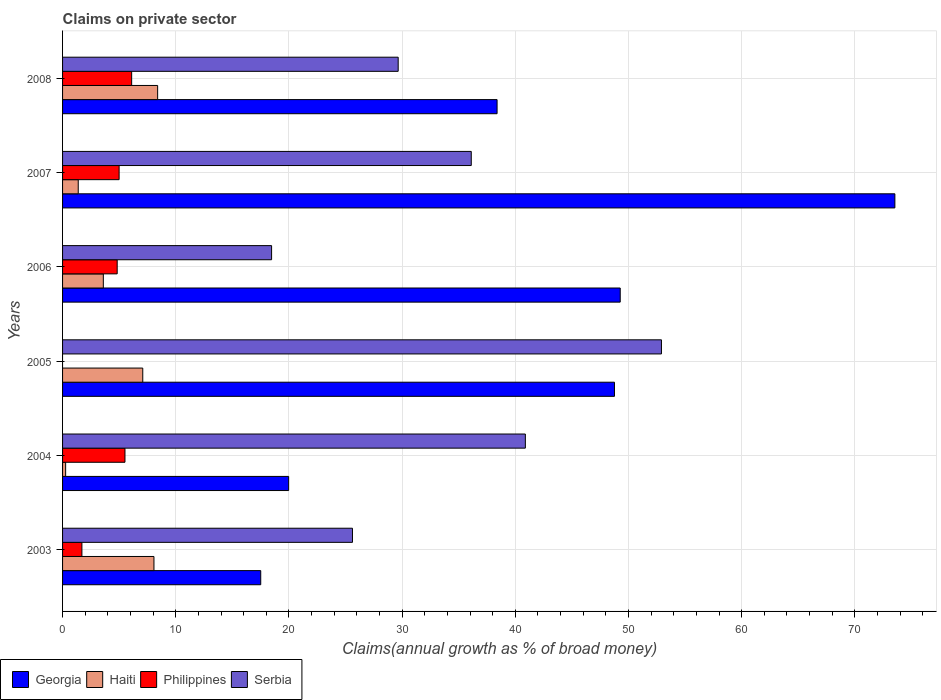What is the label of the 3rd group of bars from the top?
Give a very brief answer. 2006. In how many cases, is the number of bars for a given year not equal to the number of legend labels?
Give a very brief answer. 1. What is the percentage of broad money claimed on private sector in Serbia in 2004?
Make the answer very short. 40.89. Across all years, what is the maximum percentage of broad money claimed on private sector in Haiti?
Your answer should be compact. 8.4. Across all years, what is the minimum percentage of broad money claimed on private sector in Georgia?
Offer a terse response. 17.51. What is the total percentage of broad money claimed on private sector in Philippines in the graph?
Keep it short and to the point. 23.15. What is the difference between the percentage of broad money claimed on private sector in Georgia in 2003 and that in 2004?
Keep it short and to the point. -2.47. What is the difference between the percentage of broad money claimed on private sector in Serbia in 2006 and the percentage of broad money claimed on private sector in Georgia in 2005?
Provide a short and direct response. -30.29. What is the average percentage of broad money claimed on private sector in Philippines per year?
Provide a short and direct response. 3.86. In the year 2006, what is the difference between the percentage of broad money claimed on private sector in Serbia and percentage of broad money claimed on private sector in Georgia?
Your response must be concise. -30.8. What is the ratio of the percentage of broad money claimed on private sector in Philippines in 2006 to that in 2007?
Keep it short and to the point. 0.97. What is the difference between the highest and the second highest percentage of broad money claimed on private sector in Georgia?
Keep it short and to the point. 24.27. What is the difference between the highest and the lowest percentage of broad money claimed on private sector in Haiti?
Offer a terse response. 8.13. In how many years, is the percentage of broad money claimed on private sector in Philippines greater than the average percentage of broad money claimed on private sector in Philippines taken over all years?
Ensure brevity in your answer.  4. Is the sum of the percentage of broad money claimed on private sector in Georgia in 2004 and 2008 greater than the maximum percentage of broad money claimed on private sector in Philippines across all years?
Your response must be concise. Yes. Is it the case that in every year, the sum of the percentage of broad money claimed on private sector in Georgia and percentage of broad money claimed on private sector in Philippines is greater than the percentage of broad money claimed on private sector in Haiti?
Your answer should be compact. Yes. How many bars are there?
Your answer should be very brief. 23. Does the graph contain any zero values?
Your answer should be very brief. Yes. Where does the legend appear in the graph?
Offer a very short reply. Bottom left. What is the title of the graph?
Ensure brevity in your answer.  Claims on private sector. Does "Mexico" appear as one of the legend labels in the graph?
Make the answer very short. No. What is the label or title of the X-axis?
Offer a very short reply. Claims(annual growth as % of broad money). What is the label or title of the Y-axis?
Your answer should be very brief. Years. What is the Claims(annual growth as % of broad money) of Georgia in 2003?
Ensure brevity in your answer.  17.51. What is the Claims(annual growth as % of broad money) in Haiti in 2003?
Provide a succinct answer. 8.08. What is the Claims(annual growth as % of broad money) in Philippines in 2003?
Provide a succinct answer. 1.71. What is the Claims(annual growth as % of broad money) in Serbia in 2003?
Ensure brevity in your answer.  25.61. What is the Claims(annual growth as % of broad money) in Georgia in 2004?
Your response must be concise. 19.98. What is the Claims(annual growth as % of broad money) of Haiti in 2004?
Offer a terse response. 0.27. What is the Claims(annual growth as % of broad money) of Philippines in 2004?
Offer a very short reply. 5.51. What is the Claims(annual growth as % of broad money) in Serbia in 2004?
Provide a succinct answer. 40.89. What is the Claims(annual growth as % of broad money) in Georgia in 2005?
Your response must be concise. 48.76. What is the Claims(annual growth as % of broad money) in Haiti in 2005?
Your answer should be compact. 7.09. What is the Claims(annual growth as % of broad money) of Philippines in 2005?
Make the answer very short. 0. What is the Claims(annual growth as % of broad money) of Serbia in 2005?
Offer a terse response. 52.91. What is the Claims(annual growth as % of broad money) in Georgia in 2006?
Give a very brief answer. 49.27. What is the Claims(annual growth as % of broad money) in Haiti in 2006?
Give a very brief answer. 3.6. What is the Claims(annual growth as % of broad money) in Philippines in 2006?
Your answer should be very brief. 4.83. What is the Claims(annual growth as % of broad money) in Serbia in 2006?
Provide a succinct answer. 18.47. What is the Claims(annual growth as % of broad money) in Georgia in 2007?
Ensure brevity in your answer.  73.54. What is the Claims(annual growth as % of broad money) in Haiti in 2007?
Make the answer very short. 1.38. What is the Claims(annual growth as % of broad money) in Philippines in 2007?
Your answer should be compact. 5. What is the Claims(annual growth as % of broad money) in Serbia in 2007?
Your response must be concise. 36.11. What is the Claims(annual growth as % of broad money) of Georgia in 2008?
Offer a terse response. 38.39. What is the Claims(annual growth as % of broad money) in Haiti in 2008?
Keep it short and to the point. 8.4. What is the Claims(annual growth as % of broad money) in Philippines in 2008?
Provide a succinct answer. 6.1. What is the Claims(annual growth as % of broad money) of Serbia in 2008?
Keep it short and to the point. 29.65. Across all years, what is the maximum Claims(annual growth as % of broad money) in Georgia?
Ensure brevity in your answer.  73.54. Across all years, what is the maximum Claims(annual growth as % of broad money) of Haiti?
Offer a very short reply. 8.4. Across all years, what is the maximum Claims(annual growth as % of broad money) of Philippines?
Give a very brief answer. 6.1. Across all years, what is the maximum Claims(annual growth as % of broad money) of Serbia?
Offer a terse response. 52.91. Across all years, what is the minimum Claims(annual growth as % of broad money) of Georgia?
Give a very brief answer. 17.51. Across all years, what is the minimum Claims(annual growth as % of broad money) in Haiti?
Offer a terse response. 0.27. Across all years, what is the minimum Claims(annual growth as % of broad money) of Philippines?
Your answer should be very brief. 0. Across all years, what is the minimum Claims(annual growth as % of broad money) of Serbia?
Give a very brief answer. 18.47. What is the total Claims(annual growth as % of broad money) of Georgia in the graph?
Ensure brevity in your answer.  247.45. What is the total Claims(annual growth as % of broad money) in Haiti in the graph?
Offer a very short reply. 28.82. What is the total Claims(annual growth as % of broad money) in Philippines in the graph?
Give a very brief answer. 23.15. What is the total Claims(annual growth as % of broad money) in Serbia in the graph?
Make the answer very short. 203.65. What is the difference between the Claims(annual growth as % of broad money) of Georgia in 2003 and that in 2004?
Give a very brief answer. -2.47. What is the difference between the Claims(annual growth as % of broad money) in Haiti in 2003 and that in 2004?
Offer a very short reply. 7.8. What is the difference between the Claims(annual growth as % of broad money) of Philippines in 2003 and that in 2004?
Your response must be concise. -3.8. What is the difference between the Claims(annual growth as % of broad money) of Serbia in 2003 and that in 2004?
Your response must be concise. -15.28. What is the difference between the Claims(annual growth as % of broad money) in Georgia in 2003 and that in 2005?
Offer a very short reply. -31.25. What is the difference between the Claims(annual growth as % of broad money) of Haiti in 2003 and that in 2005?
Ensure brevity in your answer.  0.99. What is the difference between the Claims(annual growth as % of broad money) in Serbia in 2003 and that in 2005?
Offer a terse response. -27.3. What is the difference between the Claims(annual growth as % of broad money) in Georgia in 2003 and that in 2006?
Your response must be concise. -31.76. What is the difference between the Claims(annual growth as % of broad money) of Haiti in 2003 and that in 2006?
Keep it short and to the point. 4.47. What is the difference between the Claims(annual growth as % of broad money) of Philippines in 2003 and that in 2006?
Offer a very short reply. -3.12. What is the difference between the Claims(annual growth as % of broad money) of Serbia in 2003 and that in 2006?
Offer a terse response. 7.15. What is the difference between the Claims(annual growth as % of broad money) in Georgia in 2003 and that in 2007?
Give a very brief answer. -56.03. What is the difference between the Claims(annual growth as % of broad money) in Haiti in 2003 and that in 2007?
Ensure brevity in your answer.  6.69. What is the difference between the Claims(annual growth as % of broad money) of Philippines in 2003 and that in 2007?
Offer a very short reply. -3.29. What is the difference between the Claims(annual growth as % of broad money) in Serbia in 2003 and that in 2007?
Your answer should be compact. -10.5. What is the difference between the Claims(annual growth as % of broad money) in Georgia in 2003 and that in 2008?
Your response must be concise. -20.88. What is the difference between the Claims(annual growth as % of broad money) in Haiti in 2003 and that in 2008?
Make the answer very short. -0.33. What is the difference between the Claims(annual growth as % of broad money) of Philippines in 2003 and that in 2008?
Offer a very short reply. -4.4. What is the difference between the Claims(annual growth as % of broad money) in Serbia in 2003 and that in 2008?
Ensure brevity in your answer.  -4.04. What is the difference between the Claims(annual growth as % of broad money) in Georgia in 2004 and that in 2005?
Provide a succinct answer. -28.79. What is the difference between the Claims(annual growth as % of broad money) of Haiti in 2004 and that in 2005?
Offer a very short reply. -6.81. What is the difference between the Claims(annual growth as % of broad money) of Serbia in 2004 and that in 2005?
Your answer should be very brief. -12.02. What is the difference between the Claims(annual growth as % of broad money) of Georgia in 2004 and that in 2006?
Provide a succinct answer. -29.3. What is the difference between the Claims(annual growth as % of broad money) of Haiti in 2004 and that in 2006?
Offer a terse response. -3.33. What is the difference between the Claims(annual growth as % of broad money) in Philippines in 2004 and that in 2006?
Your response must be concise. 0.69. What is the difference between the Claims(annual growth as % of broad money) in Serbia in 2004 and that in 2006?
Make the answer very short. 22.42. What is the difference between the Claims(annual growth as % of broad money) of Georgia in 2004 and that in 2007?
Your response must be concise. -53.56. What is the difference between the Claims(annual growth as % of broad money) in Haiti in 2004 and that in 2007?
Ensure brevity in your answer.  -1.11. What is the difference between the Claims(annual growth as % of broad money) of Philippines in 2004 and that in 2007?
Your answer should be very brief. 0.52. What is the difference between the Claims(annual growth as % of broad money) of Serbia in 2004 and that in 2007?
Provide a succinct answer. 4.78. What is the difference between the Claims(annual growth as % of broad money) in Georgia in 2004 and that in 2008?
Offer a terse response. -18.42. What is the difference between the Claims(annual growth as % of broad money) of Haiti in 2004 and that in 2008?
Make the answer very short. -8.13. What is the difference between the Claims(annual growth as % of broad money) of Philippines in 2004 and that in 2008?
Make the answer very short. -0.59. What is the difference between the Claims(annual growth as % of broad money) of Serbia in 2004 and that in 2008?
Provide a short and direct response. 11.24. What is the difference between the Claims(annual growth as % of broad money) in Georgia in 2005 and that in 2006?
Your response must be concise. -0.51. What is the difference between the Claims(annual growth as % of broad money) of Haiti in 2005 and that in 2006?
Your answer should be compact. 3.48. What is the difference between the Claims(annual growth as % of broad money) in Serbia in 2005 and that in 2006?
Provide a short and direct response. 34.45. What is the difference between the Claims(annual growth as % of broad money) of Georgia in 2005 and that in 2007?
Make the answer very short. -24.78. What is the difference between the Claims(annual growth as % of broad money) of Haiti in 2005 and that in 2007?
Provide a succinct answer. 5.7. What is the difference between the Claims(annual growth as % of broad money) of Serbia in 2005 and that in 2007?
Give a very brief answer. 16.8. What is the difference between the Claims(annual growth as % of broad money) of Georgia in 2005 and that in 2008?
Offer a very short reply. 10.37. What is the difference between the Claims(annual growth as % of broad money) of Haiti in 2005 and that in 2008?
Your response must be concise. -1.32. What is the difference between the Claims(annual growth as % of broad money) in Serbia in 2005 and that in 2008?
Provide a succinct answer. 23.26. What is the difference between the Claims(annual growth as % of broad money) of Georgia in 2006 and that in 2007?
Keep it short and to the point. -24.27. What is the difference between the Claims(annual growth as % of broad money) in Haiti in 2006 and that in 2007?
Your answer should be very brief. 2.22. What is the difference between the Claims(annual growth as % of broad money) in Philippines in 2006 and that in 2007?
Provide a short and direct response. -0.17. What is the difference between the Claims(annual growth as % of broad money) of Serbia in 2006 and that in 2007?
Offer a terse response. -17.64. What is the difference between the Claims(annual growth as % of broad money) of Georgia in 2006 and that in 2008?
Your answer should be very brief. 10.88. What is the difference between the Claims(annual growth as % of broad money) in Haiti in 2006 and that in 2008?
Provide a short and direct response. -4.8. What is the difference between the Claims(annual growth as % of broad money) of Philippines in 2006 and that in 2008?
Offer a terse response. -1.28. What is the difference between the Claims(annual growth as % of broad money) of Serbia in 2006 and that in 2008?
Provide a short and direct response. -11.18. What is the difference between the Claims(annual growth as % of broad money) in Georgia in 2007 and that in 2008?
Make the answer very short. 35.15. What is the difference between the Claims(annual growth as % of broad money) of Haiti in 2007 and that in 2008?
Give a very brief answer. -7.02. What is the difference between the Claims(annual growth as % of broad money) in Philippines in 2007 and that in 2008?
Keep it short and to the point. -1.11. What is the difference between the Claims(annual growth as % of broad money) in Serbia in 2007 and that in 2008?
Offer a very short reply. 6.46. What is the difference between the Claims(annual growth as % of broad money) in Georgia in 2003 and the Claims(annual growth as % of broad money) in Haiti in 2004?
Provide a succinct answer. 17.24. What is the difference between the Claims(annual growth as % of broad money) of Georgia in 2003 and the Claims(annual growth as % of broad money) of Philippines in 2004?
Your answer should be very brief. 12. What is the difference between the Claims(annual growth as % of broad money) of Georgia in 2003 and the Claims(annual growth as % of broad money) of Serbia in 2004?
Your answer should be very brief. -23.38. What is the difference between the Claims(annual growth as % of broad money) of Haiti in 2003 and the Claims(annual growth as % of broad money) of Philippines in 2004?
Keep it short and to the point. 2.56. What is the difference between the Claims(annual growth as % of broad money) in Haiti in 2003 and the Claims(annual growth as % of broad money) in Serbia in 2004?
Provide a short and direct response. -32.81. What is the difference between the Claims(annual growth as % of broad money) of Philippines in 2003 and the Claims(annual growth as % of broad money) of Serbia in 2004?
Offer a terse response. -39.18. What is the difference between the Claims(annual growth as % of broad money) of Georgia in 2003 and the Claims(annual growth as % of broad money) of Haiti in 2005?
Offer a terse response. 10.42. What is the difference between the Claims(annual growth as % of broad money) in Georgia in 2003 and the Claims(annual growth as % of broad money) in Serbia in 2005?
Your response must be concise. -35.4. What is the difference between the Claims(annual growth as % of broad money) of Haiti in 2003 and the Claims(annual growth as % of broad money) of Serbia in 2005?
Your response must be concise. -44.84. What is the difference between the Claims(annual growth as % of broad money) in Philippines in 2003 and the Claims(annual growth as % of broad money) in Serbia in 2005?
Offer a very short reply. -51.21. What is the difference between the Claims(annual growth as % of broad money) of Georgia in 2003 and the Claims(annual growth as % of broad money) of Haiti in 2006?
Your answer should be compact. 13.91. What is the difference between the Claims(annual growth as % of broad money) in Georgia in 2003 and the Claims(annual growth as % of broad money) in Philippines in 2006?
Make the answer very short. 12.68. What is the difference between the Claims(annual growth as % of broad money) in Georgia in 2003 and the Claims(annual growth as % of broad money) in Serbia in 2006?
Provide a succinct answer. -0.96. What is the difference between the Claims(annual growth as % of broad money) of Haiti in 2003 and the Claims(annual growth as % of broad money) of Philippines in 2006?
Make the answer very short. 3.25. What is the difference between the Claims(annual growth as % of broad money) in Haiti in 2003 and the Claims(annual growth as % of broad money) in Serbia in 2006?
Your response must be concise. -10.39. What is the difference between the Claims(annual growth as % of broad money) of Philippines in 2003 and the Claims(annual growth as % of broad money) of Serbia in 2006?
Your response must be concise. -16.76. What is the difference between the Claims(annual growth as % of broad money) in Georgia in 2003 and the Claims(annual growth as % of broad money) in Haiti in 2007?
Your answer should be very brief. 16.13. What is the difference between the Claims(annual growth as % of broad money) in Georgia in 2003 and the Claims(annual growth as % of broad money) in Philippines in 2007?
Ensure brevity in your answer.  12.51. What is the difference between the Claims(annual growth as % of broad money) in Georgia in 2003 and the Claims(annual growth as % of broad money) in Serbia in 2007?
Ensure brevity in your answer.  -18.6. What is the difference between the Claims(annual growth as % of broad money) of Haiti in 2003 and the Claims(annual growth as % of broad money) of Philippines in 2007?
Give a very brief answer. 3.08. What is the difference between the Claims(annual growth as % of broad money) of Haiti in 2003 and the Claims(annual growth as % of broad money) of Serbia in 2007?
Offer a terse response. -28.04. What is the difference between the Claims(annual growth as % of broad money) of Philippines in 2003 and the Claims(annual growth as % of broad money) of Serbia in 2007?
Offer a very short reply. -34.4. What is the difference between the Claims(annual growth as % of broad money) in Georgia in 2003 and the Claims(annual growth as % of broad money) in Haiti in 2008?
Offer a terse response. 9.11. What is the difference between the Claims(annual growth as % of broad money) of Georgia in 2003 and the Claims(annual growth as % of broad money) of Philippines in 2008?
Offer a very short reply. 11.41. What is the difference between the Claims(annual growth as % of broad money) in Georgia in 2003 and the Claims(annual growth as % of broad money) in Serbia in 2008?
Keep it short and to the point. -12.14. What is the difference between the Claims(annual growth as % of broad money) of Haiti in 2003 and the Claims(annual growth as % of broad money) of Philippines in 2008?
Make the answer very short. 1.97. What is the difference between the Claims(annual growth as % of broad money) in Haiti in 2003 and the Claims(annual growth as % of broad money) in Serbia in 2008?
Keep it short and to the point. -21.58. What is the difference between the Claims(annual growth as % of broad money) of Philippines in 2003 and the Claims(annual growth as % of broad money) of Serbia in 2008?
Your answer should be very brief. -27.94. What is the difference between the Claims(annual growth as % of broad money) in Georgia in 2004 and the Claims(annual growth as % of broad money) in Haiti in 2005?
Make the answer very short. 12.89. What is the difference between the Claims(annual growth as % of broad money) of Georgia in 2004 and the Claims(annual growth as % of broad money) of Serbia in 2005?
Offer a very short reply. -32.94. What is the difference between the Claims(annual growth as % of broad money) of Haiti in 2004 and the Claims(annual growth as % of broad money) of Serbia in 2005?
Your response must be concise. -52.64. What is the difference between the Claims(annual growth as % of broad money) of Philippines in 2004 and the Claims(annual growth as % of broad money) of Serbia in 2005?
Make the answer very short. -47.4. What is the difference between the Claims(annual growth as % of broad money) of Georgia in 2004 and the Claims(annual growth as % of broad money) of Haiti in 2006?
Your answer should be very brief. 16.38. What is the difference between the Claims(annual growth as % of broad money) in Georgia in 2004 and the Claims(annual growth as % of broad money) in Philippines in 2006?
Your answer should be compact. 15.15. What is the difference between the Claims(annual growth as % of broad money) of Georgia in 2004 and the Claims(annual growth as % of broad money) of Serbia in 2006?
Give a very brief answer. 1.51. What is the difference between the Claims(annual growth as % of broad money) of Haiti in 2004 and the Claims(annual growth as % of broad money) of Philippines in 2006?
Provide a succinct answer. -4.56. What is the difference between the Claims(annual growth as % of broad money) in Haiti in 2004 and the Claims(annual growth as % of broad money) in Serbia in 2006?
Make the answer very short. -18.2. What is the difference between the Claims(annual growth as % of broad money) in Philippines in 2004 and the Claims(annual growth as % of broad money) in Serbia in 2006?
Offer a terse response. -12.96. What is the difference between the Claims(annual growth as % of broad money) of Georgia in 2004 and the Claims(annual growth as % of broad money) of Haiti in 2007?
Your answer should be very brief. 18.59. What is the difference between the Claims(annual growth as % of broad money) of Georgia in 2004 and the Claims(annual growth as % of broad money) of Philippines in 2007?
Give a very brief answer. 14.98. What is the difference between the Claims(annual growth as % of broad money) in Georgia in 2004 and the Claims(annual growth as % of broad money) in Serbia in 2007?
Provide a short and direct response. -16.13. What is the difference between the Claims(annual growth as % of broad money) in Haiti in 2004 and the Claims(annual growth as % of broad money) in Philippines in 2007?
Provide a short and direct response. -4.73. What is the difference between the Claims(annual growth as % of broad money) of Haiti in 2004 and the Claims(annual growth as % of broad money) of Serbia in 2007?
Give a very brief answer. -35.84. What is the difference between the Claims(annual growth as % of broad money) in Philippines in 2004 and the Claims(annual growth as % of broad money) in Serbia in 2007?
Keep it short and to the point. -30.6. What is the difference between the Claims(annual growth as % of broad money) of Georgia in 2004 and the Claims(annual growth as % of broad money) of Haiti in 2008?
Your response must be concise. 11.58. What is the difference between the Claims(annual growth as % of broad money) of Georgia in 2004 and the Claims(annual growth as % of broad money) of Philippines in 2008?
Give a very brief answer. 13.87. What is the difference between the Claims(annual growth as % of broad money) in Georgia in 2004 and the Claims(annual growth as % of broad money) in Serbia in 2008?
Provide a short and direct response. -9.68. What is the difference between the Claims(annual growth as % of broad money) of Haiti in 2004 and the Claims(annual growth as % of broad money) of Philippines in 2008?
Your response must be concise. -5.83. What is the difference between the Claims(annual growth as % of broad money) of Haiti in 2004 and the Claims(annual growth as % of broad money) of Serbia in 2008?
Make the answer very short. -29.38. What is the difference between the Claims(annual growth as % of broad money) of Philippines in 2004 and the Claims(annual growth as % of broad money) of Serbia in 2008?
Your answer should be very brief. -24.14. What is the difference between the Claims(annual growth as % of broad money) of Georgia in 2005 and the Claims(annual growth as % of broad money) of Haiti in 2006?
Provide a succinct answer. 45.16. What is the difference between the Claims(annual growth as % of broad money) in Georgia in 2005 and the Claims(annual growth as % of broad money) in Philippines in 2006?
Offer a very short reply. 43.94. What is the difference between the Claims(annual growth as % of broad money) of Georgia in 2005 and the Claims(annual growth as % of broad money) of Serbia in 2006?
Offer a very short reply. 30.29. What is the difference between the Claims(annual growth as % of broad money) of Haiti in 2005 and the Claims(annual growth as % of broad money) of Philippines in 2006?
Provide a short and direct response. 2.26. What is the difference between the Claims(annual growth as % of broad money) of Haiti in 2005 and the Claims(annual growth as % of broad money) of Serbia in 2006?
Offer a very short reply. -11.38. What is the difference between the Claims(annual growth as % of broad money) in Georgia in 2005 and the Claims(annual growth as % of broad money) in Haiti in 2007?
Make the answer very short. 47.38. What is the difference between the Claims(annual growth as % of broad money) of Georgia in 2005 and the Claims(annual growth as % of broad money) of Philippines in 2007?
Your answer should be compact. 43.77. What is the difference between the Claims(annual growth as % of broad money) in Georgia in 2005 and the Claims(annual growth as % of broad money) in Serbia in 2007?
Your answer should be very brief. 12.65. What is the difference between the Claims(annual growth as % of broad money) of Haiti in 2005 and the Claims(annual growth as % of broad money) of Philippines in 2007?
Make the answer very short. 2.09. What is the difference between the Claims(annual growth as % of broad money) of Haiti in 2005 and the Claims(annual growth as % of broad money) of Serbia in 2007?
Keep it short and to the point. -29.03. What is the difference between the Claims(annual growth as % of broad money) of Georgia in 2005 and the Claims(annual growth as % of broad money) of Haiti in 2008?
Your answer should be compact. 40.36. What is the difference between the Claims(annual growth as % of broad money) of Georgia in 2005 and the Claims(annual growth as % of broad money) of Philippines in 2008?
Provide a short and direct response. 42.66. What is the difference between the Claims(annual growth as % of broad money) of Georgia in 2005 and the Claims(annual growth as % of broad money) of Serbia in 2008?
Your response must be concise. 19.11. What is the difference between the Claims(annual growth as % of broad money) of Haiti in 2005 and the Claims(annual growth as % of broad money) of Philippines in 2008?
Provide a short and direct response. 0.98. What is the difference between the Claims(annual growth as % of broad money) of Haiti in 2005 and the Claims(annual growth as % of broad money) of Serbia in 2008?
Keep it short and to the point. -22.57. What is the difference between the Claims(annual growth as % of broad money) in Georgia in 2006 and the Claims(annual growth as % of broad money) in Haiti in 2007?
Your answer should be compact. 47.89. What is the difference between the Claims(annual growth as % of broad money) in Georgia in 2006 and the Claims(annual growth as % of broad money) in Philippines in 2007?
Keep it short and to the point. 44.28. What is the difference between the Claims(annual growth as % of broad money) in Georgia in 2006 and the Claims(annual growth as % of broad money) in Serbia in 2007?
Your answer should be very brief. 13.16. What is the difference between the Claims(annual growth as % of broad money) in Haiti in 2006 and the Claims(annual growth as % of broad money) in Philippines in 2007?
Provide a short and direct response. -1.4. What is the difference between the Claims(annual growth as % of broad money) of Haiti in 2006 and the Claims(annual growth as % of broad money) of Serbia in 2007?
Make the answer very short. -32.51. What is the difference between the Claims(annual growth as % of broad money) in Philippines in 2006 and the Claims(annual growth as % of broad money) in Serbia in 2007?
Provide a succinct answer. -31.28. What is the difference between the Claims(annual growth as % of broad money) of Georgia in 2006 and the Claims(annual growth as % of broad money) of Haiti in 2008?
Give a very brief answer. 40.87. What is the difference between the Claims(annual growth as % of broad money) of Georgia in 2006 and the Claims(annual growth as % of broad money) of Philippines in 2008?
Provide a short and direct response. 43.17. What is the difference between the Claims(annual growth as % of broad money) of Georgia in 2006 and the Claims(annual growth as % of broad money) of Serbia in 2008?
Provide a succinct answer. 19.62. What is the difference between the Claims(annual growth as % of broad money) in Haiti in 2006 and the Claims(annual growth as % of broad money) in Philippines in 2008?
Your response must be concise. -2.5. What is the difference between the Claims(annual growth as % of broad money) in Haiti in 2006 and the Claims(annual growth as % of broad money) in Serbia in 2008?
Offer a terse response. -26.05. What is the difference between the Claims(annual growth as % of broad money) of Philippines in 2006 and the Claims(annual growth as % of broad money) of Serbia in 2008?
Provide a succinct answer. -24.83. What is the difference between the Claims(annual growth as % of broad money) in Georgia in 2007 and the Claims(annual growth as % of broad money) in Haiti in 2008?
Offer a terse response. 65.14. What is the difference between the Claims(annual growth as % of broad money) in Georgia in 2007 and the Claims(annual growth as % of broad money) in Philippines in 2008?
Ensure brevity in your answer.  67.43. What is the difference between the Claims(annual growth as % of broad money) of Georgia in 2007 and the Claims(annual growth as % of broad money) of Serbia in 2008?
Keep it short and to the point. 43.89. What is the difference between the Claims(annual growth as % of broad money) of Haiti in 2007 and the Claims(annual growth as % of broad money) of Philippines in 2008?
Make the answer very short. -4.72. What is the difference between the Claims(annual growth as % of broad money) in Haiti in 2007 and the Claims(annual growth as % of broad money) in Serbia in 2008?
Keep it short and to the point. -28.27. What is the difference between the Claims(annual growth as % of broad money) in Philippines in 2007 and the Claims(annual growth as % of broad money) in Serbia in 2008?
Make the answer very short. -24.66. What is the average Claims(annual growth as % of broad money) of Georgia per year?
Offer a terse response. 41.24. What is the average Claims(annual growth as % of broad money) of Haiti per year?
Provide a succinct answer. 4.8. What is the average Claims(annual growth as % of broad money) of Philippines per year?
Give a very brief answer. 3.86. What is the average Claims(annual growth as % of broad money) in Serbia per year?
Give a very brief answer. 33.94. In the year 2003, what is the difference between the Claims(annual growth as % of broad money) of Georgia and Claims(annual growth as % of broad money) of Haiti?
Provide a short and direct response. 9.43. In the year 2003, what is the difference between the Claims(annual growth as % of broad money) of Georgia and Claims(annual growth as % of broad money) of Philippines?
Provide a short and direct response. 15.8. In the year 2003, what is the difference between the Claims(annual growth as % of broad money) in Georgia and Claims(annual growth as % of broad money) in Serbia?
Keep it short and to the point. -8.1. In the year 2003, what is the difference between the Claims(annual growth as % of broad money) in Haiti and Claims(annual growth as % of broad money) in Philippines?
Your answer should be very brief. 6.37. In the year 2003, what is the difference between the Claims(annual growth as % of broad money) of Haiti and Claims(annual growth as % of broad money) of Serbia?
Offer a terse response. -17.54. In the year 2003, what is the difference between the Claims(annual growth as % of broad money) in Philippines and Claims(annual growth as % of broad money) in Serbia?
Make the answer very short. -23.91. In the year 2004, what is the difference between the Claims(annual growth as % of broad money) of Georgia and Claims(annual growth as % of broad money) of Haiti?
Offer a very short reply. 19.71. In the year 2004, what is the difference between the Claims(annual growth as % of broad money) of Georgia and Claims(annual growth as % of broad money) of Philippines?
Offer a very short reply. 14.46. In the year 2004, what is the difference between the Claims(annual growth as % of broad money) in Georgia and Claims(annual growth as % of broad money) in Serbia?
Provide a succinct answer. -20.91. In the year 2004, what is the difference between the Claims(annual growth as % of broad money) of Haiti and Claims(annual growth as % of broad money) of Philippines?
Provide a succinct answer. -5.24. In the year 2004, what is the difference between the Claims(annual growth as % of broad money) in Haiti and Claims(annual growth as % of broad money) in Serbia?
Provide a short and direct response. -40.62. In the year 2004, what is the difference between the Claims(annual growth as % of broad money) in Philippines and Claims(annual growth as % of broad money) in Serbia?
Provide a succinct answer. -35.38. In the year 2005, what is the difference between the Claims(annual growth as % of broad money) of Georgia and Claims(annual growth as % of broad money) of Haiti?
Make the answer very short. 41.68. In the year 2005, what is the difference between the Claims(annual growth as % of broad money) in Georgia and Claims(annual growth as % of broad money) in Serbia?
Offer a terse response. -4.15. In the year 2005, what is the difference between the Claims(annual growth as % of broad money) of Haiti and Claims(annual growth as % of broad money) of Serbia?
Offer a very short reply. -45.83. In the year 2006, what is the difference between the Claims(annual growth as % of broad money) of Georgia and Claims(annual growth as % of broad money) of Haiti?
Your answer should be compact. 45.67. In the year 2006, what is the difference between the Claims(annual growth as % of broad money) in Georgia and Claims(annual growth as % of broad money) in Philippines?
Keep it short and to the point. 44.45. In the year 2006, what is the difference between the Claims(annual growth as % of broad money) of Georgia and Claims(annual growth as % of broad money) of Serbia?
Your answer should be compact. 30.8. In the year 2006, what is the difference between the Claims(annual growth as % of broad money) of Haiti and Claims(annual growth as % of broad money) of Philippines?
Offer a very short reply. -1.22. In the year 2006, what is the difference between the Claims(annual growth as % of broad money) in Haiti and Claims(annual growth as % of broad money) in Serbia?
Ensure brevity in your answer.  -14.87. In the year 2006, what is the difference between the Claims(annual growth as % of broad money) of Philippines and Claims(annual growth as % of broad money) of Serbia?
Make the answer very short. -13.64. In the year 2007, what is the difference between the Claims(annual growth as % of broad money) in Georgia and Claims(annual growth as % of broad money) in Haiti?
Provide a short and direct response. 72.16. In the year 2007, what is the difference between the Claims(annual growth as % of broad money) of Georgia and Claims(annual growth as % of broad money) of Philippines?
Make the answer very short. 68.54. In the year 2007, what is the difference between the Claims(annual growth as % of broad money) in Georgia and Claims(annual growth as % of broad money) in Serbia?
Your response must be concise. 37.43. In the year 2007, what is the difference between the Claims(annual growth as % of broad money) of Haiti and Claims(annual growth as % of broad money) of Philippines?
Provide a succinct answer. -3.61. In the year 2007, what is the difference between the Claims(annual growth as % of broad money) in Haiti and Claims(annual growth as % of broad money) in Serbia?
Offer a very short reply. -34.73. In the year 2007, what is the difference between the Claims(annual growth as % of broad money) of Philippines and Claims(annual growth as % of broad money) of Serbia?
Provide a succinct answer. -31.11. In the year 2008, what is the difference between the Claims(annual growth as % of broad money) in Georgia and Claims(annual growth as % of broad money) in Haiti?
Offer a very short reply. 29.99. In the year 2008, what is the difference between the Claims(annual growth as % of broad money) in Georgia and Claims(annual growth as % of broad money) in Philippines?
Keep it short and to the point. 32.29. In the year 2008, what is the difference between the Claims(annual growth as % of broad money) of Georgia and Claims(annual growth as % of broad money) of Serbia?
Your answer should be compact. 8.74. In the year 2008, what is the difference between the Claims(annual growth as % of broad money) in Haiti and Claims(annual growth as % of broad money) in Philippines?
Offer a very short reply. 2.3. In the year 2008, what is the difference between the Claims(annual growth as % of broad money) in Haiti and Claims(annual growth as % of broad money) in Serbia?
Make the answer very short. -21.25. In the year 2008, what is the difference between the Claims(annual growth as % of broad money) in Philippines and Claims(annual growth as % of broad money) in Serbia?
Your answer should be very brief. -23.55. What is the ratio of the Claims(annual growth as % of broad money) of Georgia in 2003 to that in 2004?
Ensure brevity in your answer.  0.88. What is the ratio of the Claims(annual growth as % of broad money) in Haiti in 2003 to that in 2004?
Provide a short and direct response. 29.8. What is the ratio of the Claims(annual growth as % of broad money) in Philippines in 2003 to that in 2004?
Offer a terse response. 0.31. What is the ratio of the Claims(annual growth as % of broad money) in Serbia in 2003 to that in 2004?
Provide a short and direct response. 0.63. What is the ratio of the Claims(annual growth as % of broad money) of Georgia in 2003 to that in 2005?
Provide a short and direct response. 0.36. What is the ratio of the Claims(annual growth as % of broad money) of Haiti in 2003 to that in 2005?
Your answer should be compact. 1.14. What is the ratio of the Claims(annual growth as % of broad money) of Serbia in 2003 to that in 2005?
Provide a short and direct response. 0.48. What is the ratio of the Claims(annual growth as % of broad money) of Georgia in 2003 to that in 2006?
Make the answer very short. 0.36. What is the ratio of the Claims(annual growth as % of broad money) in Haiti in 2003 to that in 2006?
Give a very brief answer. 2.24. What is the ratio of the Claims(annual growth as % of broad money) in Philippines in 2003 to that in 2006?
Offer a terse response. 0.35. What is the ratio of the Claims(annual growth as % of broad money) in Serbia in 2003 to that in 2006?
Offer a terse response. 1.39. What is the ratio of the Claims(annual growth as % of broad money) in Georgia in 2003 to that in 2007?
Your answer should be very brief. 0.24. What is the ratio of the Claims(annual growth as % of broad money) of Haiti in 2003 to that in 2007?
Your answer should be compact. 5.84. What is the ratio of the Claims(annual growth as % of broad money) of Philippines in 2003 to that in 2007?
Provide a succinct answer. 0.34. What is the ratio of the Claims(annual growth as % of broad money) of Serbia in 2003 to that in 2007?
Provide a succinct answer. 0.71. What is the ratio of the Claims(annual growth as % of broad money) in Georgia in 2003 to that in 2008?
Give a very brief answer. 0.46. What is the ratio of the Claims(annual growth as % of broad money) in Haiti in 2003 to that in 2008?
Offer a very short reply. 0.96. What is the ratio of the Claims(annual growth as % of broad money) of Philippines in 2003 to that in 2008?
Ensure brevity in your answer.  0.28. What is the ratio of the Claims(annual growth as % of broad money) of Serbia in 2003 to that in 2008?
Provide a succinct answer. 0.86. What is the ratio of the Claims(annual growth as % of broad money) of Georgia in 2004 to that in 2005?
Ensure brevity in your answer.  0.41. What is the ratio of the Claims(annual growth as % of broad money) of Haiti in 2004 to that in 2005?
Your answer should be compact. 0.04. What is the ratio of the Claims(annual growth as % of broad money) in Serbia in 2004 to that in 2005?
Your answer should be compact. 0.77. What is the ratio of the Claims(annual growth as % of broad money) of Georgia in 2004 to that in 2006?
Your response must be concise. 0.41. What is the ratio of the Claims(annual growth as % of broad money) of Haiti in 2004 to that in 2006?
Give a very brief answer. 0.08. What is the ratio of the Claims(annual growth as % of broad money) in Philippines in 2004 to that in 2006?
Keep it short and to the point. 1.14. What is the ratio of the Claims(annual growth as % of broad money) in Serbia in 2004 to that in 2006?
Your answer should be very brief. 2.21. What is the ratio of the Claims(annual growth as % of broad money) of Georgia in 2004 to that in 2007?
Give a very brief answer. 0.27. What is the ratio of the Claims(annual growth as % of broad money) in Haiti in 2004 to that in 2007?
Offer a terse response. 0.2. What is the ratio of the Claims(annual growth as % of broad money) of Philippines in 2004 to that in 2007?
Your answer should be very brief. 1.1. What is the ratio of the Claims(annual growth as % of broad money) in Serbia in 2004 to that in 2007?
Offer a terse response. 1.13. What is the ratio of the Claims(annual growth as % of broad money) of Georgia in 2004 to that in 2008?
Ensure brevity in your answer.  0.52. What is the ratio of the Claims(annual growth as % of broad money) of Haiti in 2004 to that in 2008?
Provide a short and direct response. 0.03. What is the ratio of the Claims(annual growth as % of broad money) of Philippines in 2004 to that in 2008?
Keep it short and to the point. 0.9. What is the ratio of the Claims(annual growth as % of broad money) in Serbia in 2004 to that in 2008?
Your answer should be compact. 1.38. What is the ratio of the Claims(annual growth as % of broad money) in Georgia in 2005 to that in 2006?
Keep it short and to the point. 0.99. What is the ratio of the Claims(annual growth as % of broad money) in Haiti in 2005 to that in 2006?
Your response must be concise. 1.97. What is the ratio of the Claims(annual growth as % of broad money) in Serbia in 2005 to that in 2006?
Provide a short and direct response. 2.87. What is the ratio of the Claims(annual growth as % of broad money) in Georgia in 2005 to that in 2007?
Your answer should be very brief. 0.66. What is the ratio of the Claims(annual growth as % of broad money) in Haiti in 2005 to that in 2007?
Your response must be concise. 5.12. What is the ratio of the Claims(annual growth as % of broad money) in Serbia in 2005 to that in 2007?
Offer a terse response. 1.47. What is the ratio of the Claims(annual growth as % of broad money) in Georgia in 2005 to that in 2008?
Your response must be concise. 1.27. What is the ratio of the Claims(annual growth as % of broad money) of Haiti in 2005 to that in 2008?
Offer a terse response. 0.84. What is the ratio of the Claims(annual growth as % of broad money) in Serbia in 2005 to that in 2008?
Keep it short and to the point. 1.78. What is the ratio of the Claims(annual growth as % of broad money) of Georgia in 2006 to that in 2007?
Provide a succinct answer. 0.67. What is the ratio of the Claims(annual growth as % of broad money) of Haiti in 2006 to that in 2007?
Make the answer very short. 2.6. What is the ratio of the Claims(annual growth as % of broad money) in Serbia in 2006 to that in 2007?
Keep it short and to the point. 0.51. What is the ratio of the Claims(annual growth as % of broad money) in Georgia in 2006 to that in 2008?
Your answer should be very brief. 1.28. What is the ratio of the Claims(annual growth as % of broad money) in Haiti in 2006 to that in 2008?
Ensure brevity in your answer.  0.43. What is the ratio of the Claims(annual growth as % of broad money) in Philippines in 2006 to that in 2008?
Your answer should be compact. 0.79. What is the ratio of the Claims(annual growth as % of broad money) in Serbia in 2006 to that in 2008?
Give a very brief answer. 0.62. What is the ratio of the Claims(annual growth as % of broad money) of Georgia in 2007 to that in 2008?
Ensure brevity in your answer.  1.92. What is the ratio of the Claims(annual growth as % of broad money) in Haiti in 2007 to that in 2008?
Your answer should be very brief. 0.16. What is the ratio of the Claims(annual growth as % of broad money) in Philippines in 2007 to that in 2008?
Provide a short and direct response. 0.82. What is the ratio of the Claims(annual growth as % of broad money) of Serbia in 2007 to that in 2008?
Your answer should be compact. 1.22. What is the difference between the highest and the second highest Claims(annual growth as % of broad money) of Georgia?
Provide a short and direct response. 24.27. What is the difference between the highest and the second highest Claims(annual growth as % of broad money) of Haiti?
Your response must be concise. 0.33. What is the difference between the highest and the second highest Claims(annual growth as % of broad money) in Philippines?
Ensure brevity in your answer.  0.59. What is the difference between the highest and the second highest Claims(annual growth as % of broad money) of Serbia?
Provide a succinct answer. 12.02. What is the difference between the highest and the lowest Claims(annual growth as % of broad money) of Georgia?
Make the answer very short. 56.03. What is the difference between the highest and the lowest Claims(annual growth as % of broad money) of Haiti?
Make the answer very short. 8.13. What is the difference between the highest and the lowest Claims(annual growth as % of broad money) in Philippines?
Keep it short and to the point. 6.1. What is the difference between the highest and the lowest Claims(annual growth as % of broad money) in Serbia?
Your response must be concise. 34.45. 